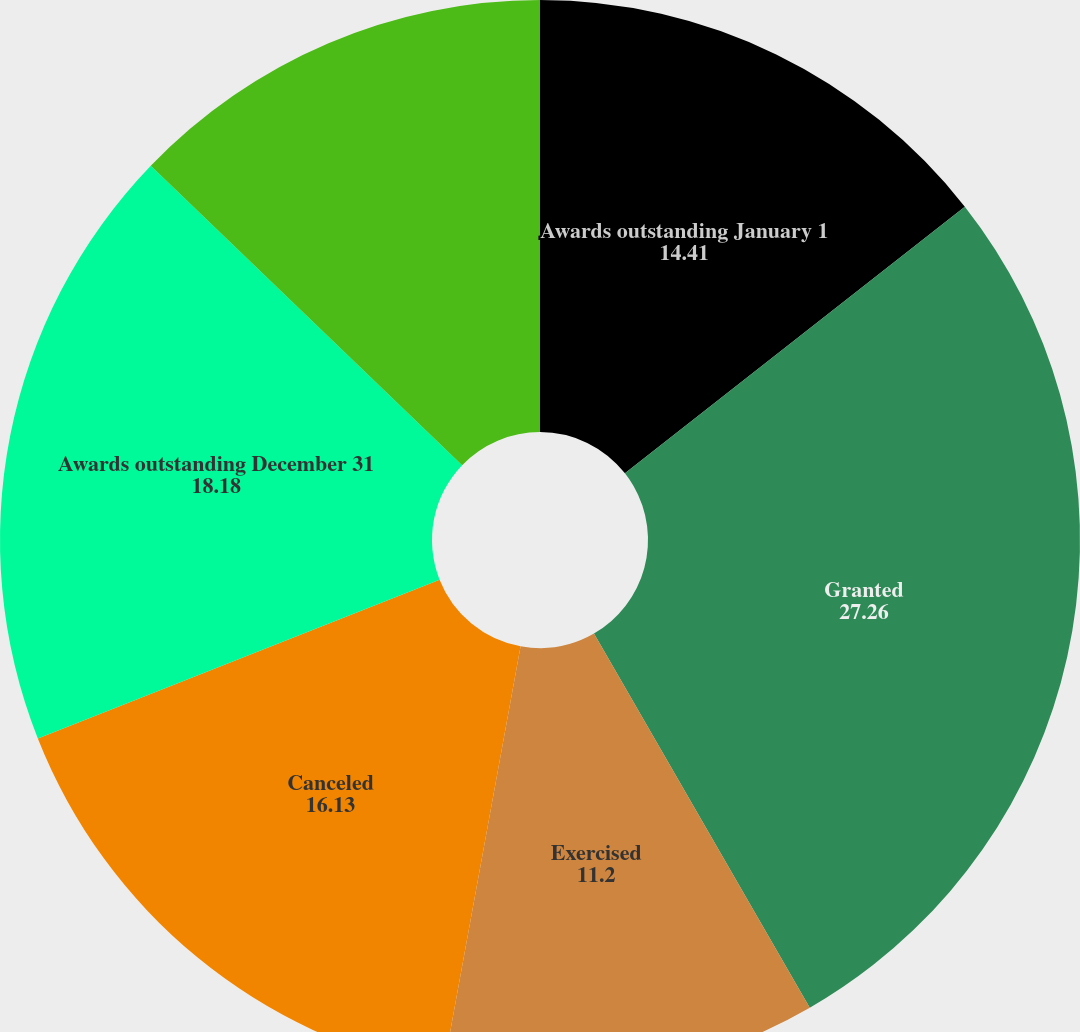Convert chart to OTSL. <chart><loc_0><loc_0><loc_500><loc_500><pie_chart><fcel>Awards outstanding January 1<fcel>Granted<fcel>Exercised<fcel>Canceled<fcel>Awards outstanding December 31<fcel>Awards exercisable December 31<nl><fcel>14.41%<fcel>27.26%<fcel>11.2%<fcel>16.13%<fcel>18.18%<fcel>12.81%<nl></chart> 